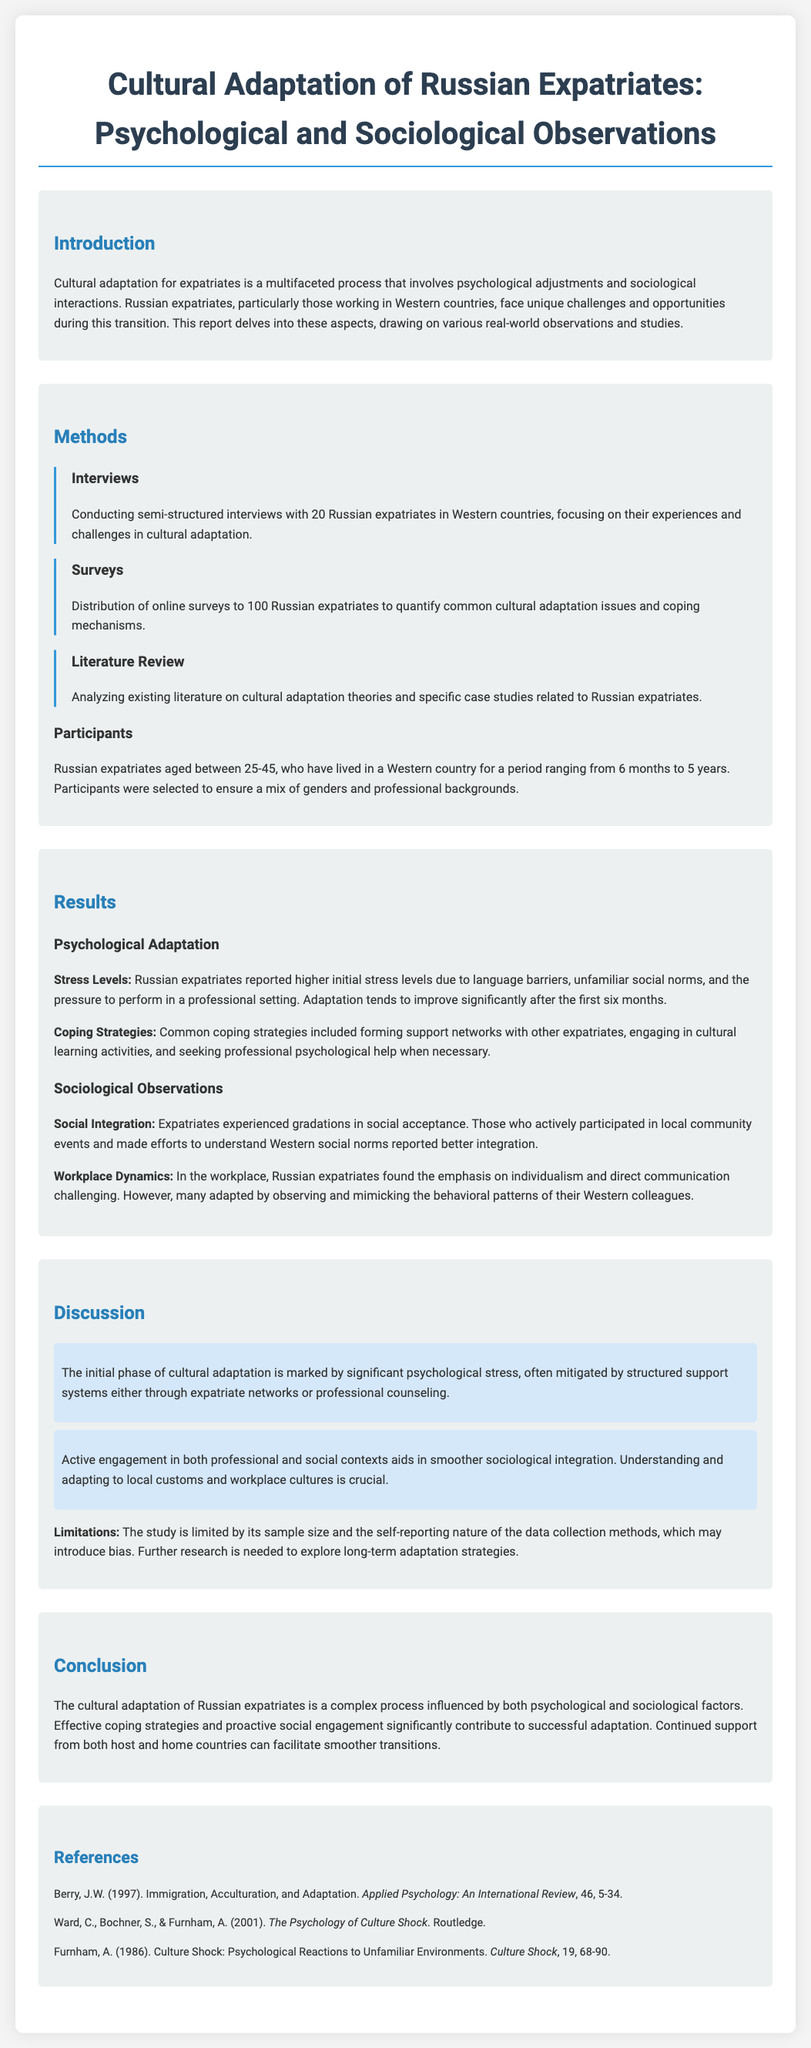What is the title of the report? The title is stated at the beginning of the document.
Answer: Cultural Adaptation of Russian Expatriates: Psychological and Sociological Observations How many Russian expatriates were interviewed? The number of expatriates interviewed is provided in the methods section.
Answer: 20 What coping strategy is mentioned for stress relief? The coping strategies listed include several methods found in the results section.
Answer: Forming support networks What age range do the participants fall into? The age range of participants is specified in the methods section.
Answer: 25-45 What is a key point about psychological stress during adaptation? Key points regarding psychological stress are outlined in the discussion section.
Answer: Marked by significant psychological stress What type of research method involved online surveys? The methods section describes the various research methodologies used in the report.
Answer: Surveys How long had participants lived in a Western country? The duration of residency for the participants is mentioned in the methods section.
Answer: 6 months to 5 years What is a limitation of the study mentioned? The limitations are discussed in the discussion section and highlight certain aspects of the study.
Answer: Sample size What factors contribute to successful adaptation according to the conclusion? The conclusion summarizes significant factors influencing adaptation found throughout the report.
Answer: Effective coping strategies and proactive social engagement 